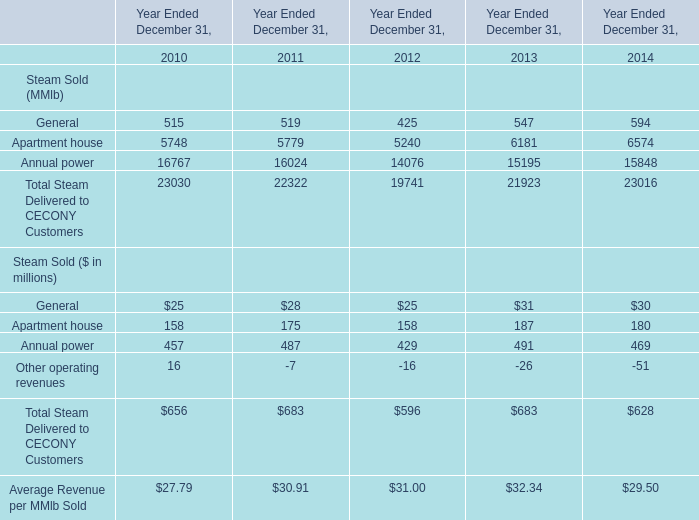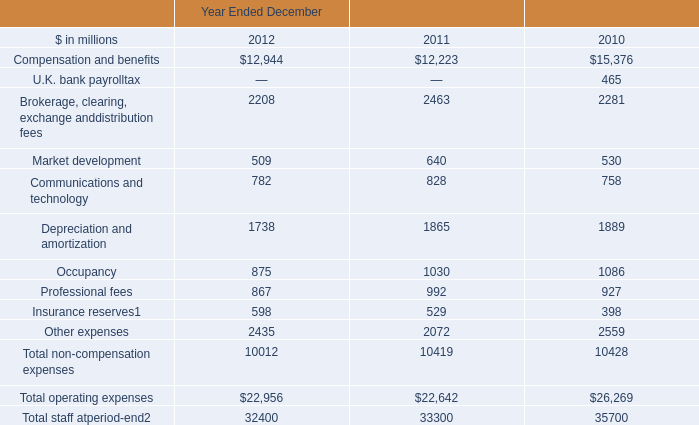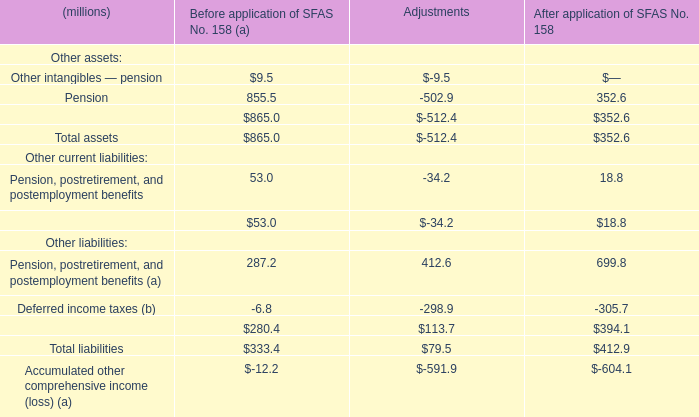What is the proportion of all Steam Sold that are greater than 100 million to the total amount of Steam Sold, in 2010? 
Computations: ((158 + 457) / (((25 + 158) + 457) + 16))
Answer: 0.9375. 